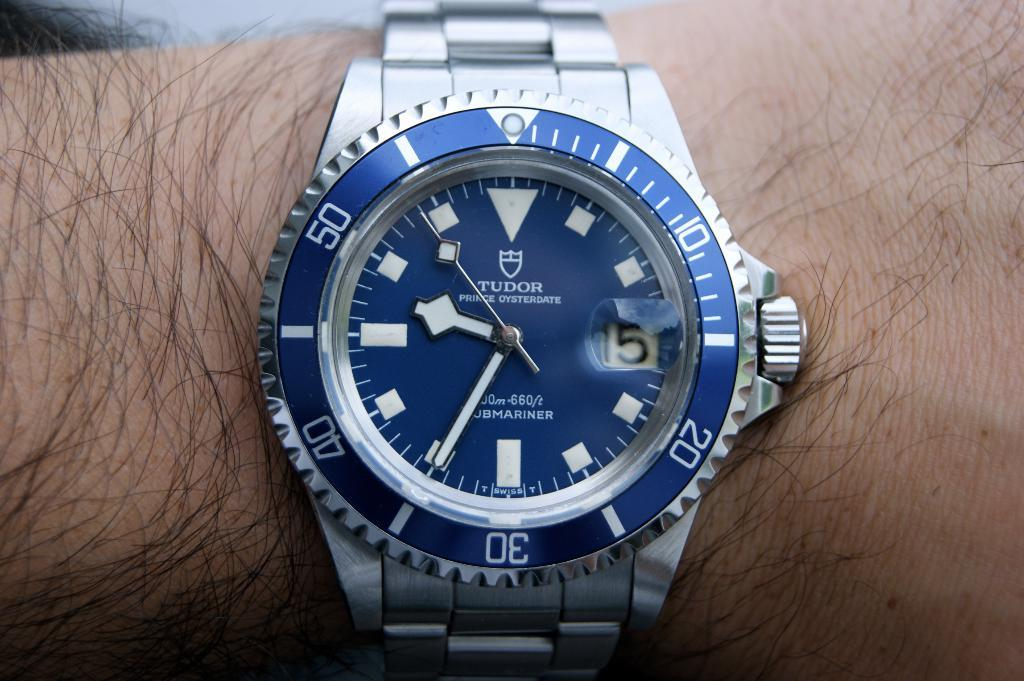Provide a one-sentence caption for the provided image. A Tudor brand wristwatch in silver and blue. 